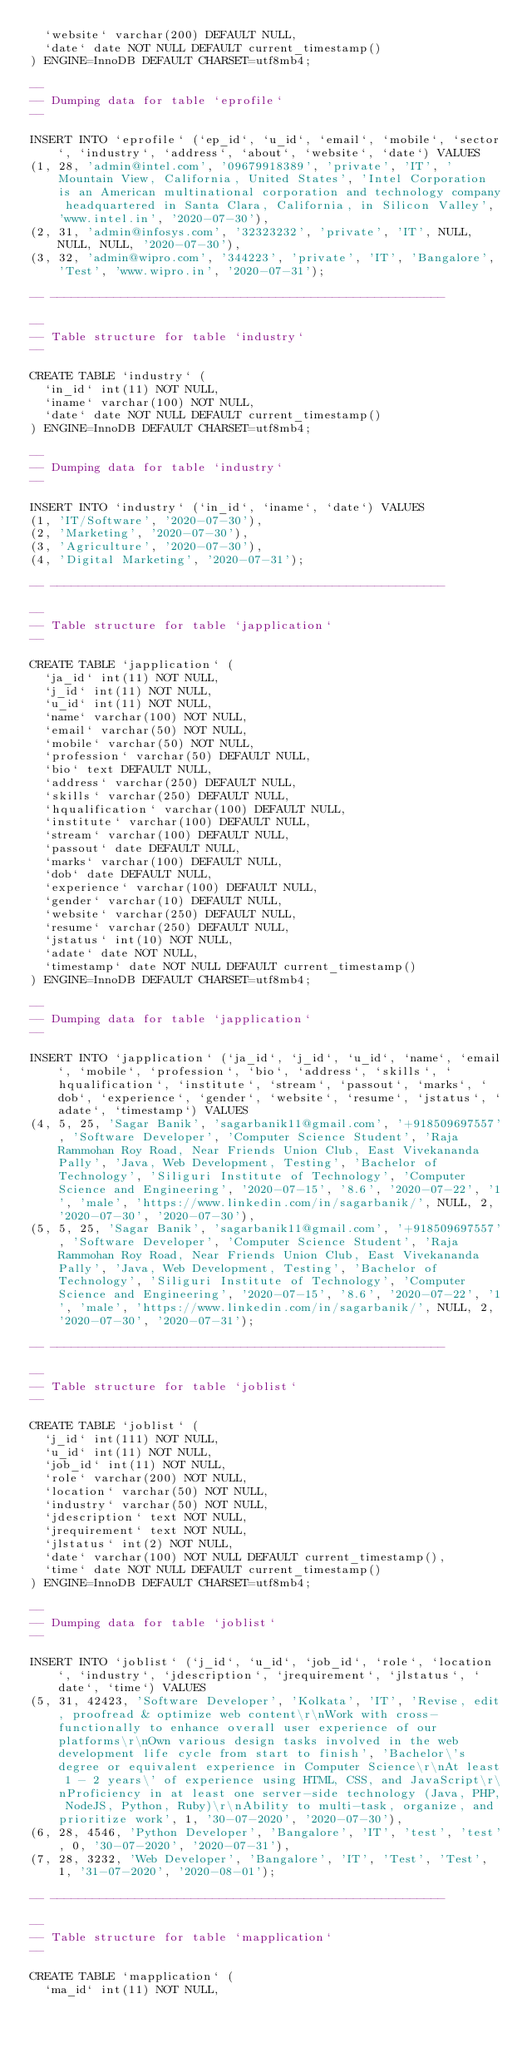Convert code to text. <code><loc_0><loc_0><loc_500><loc_500><_SQL_>  `website` varchar(200) DEFAULT NULL,
  `date` date NOT NULL DEFAULT current_timestamp()
) ENGINE=InnoDB DEFAULT CHARSET=utf8mb4;

--
-- Dumping data for table `eprofile`
--

INSERT INTO `eprofile` (`ep_id`, `u_id`, `email`, `mobile`, `sector`, `industry`, `address`, `about`, `website`, `date`) VALUES
(1, 28, 'admin@intel.com', '09679918389', 'private', 'IT', ' Mountain View, California, United States', 'Intel Corporation is an American multinational corporation and technology company headquartered in Santa Clara, California, in Silicon Valley', 'www.intel.in', '2020-07-30'),
(2, 31, 'admin@infosys.com', '32323232', 'private', 'IT', NULL, NULL, NULL, '2020-07-30'),
(3, 32, 'admin@wipro.com', '344223', 'private', 'IT', 'Bangalore', 'Test', 'www.wipro.in', '2020-07-31');

-- --------------------------------------------------------

--
-- Table structure for table `industry`
--

CREATE TABLE `industry` (
  `in_id` int(11) NOT NULL,
  `iname` varchar(100) NOT NULL,
  `date` date NOT NULL DEFAULT current_timestamp()
) ENGINE=InnoDB DEFAULT CHARSET=utf8mb4;

--
-- Dumping data for table `industry`
--

INSERT INTO `industry` (`in_id`, `iname`, `date`) VALUES
(1, 'IT/Software', '2020-07-30'),
(2, 'Marketing', '2020-07-30'),
(3, 'Agriculture', '2020-07-30'),
(4, 'Digital Marketing', '2020-07-31');

-- --------------------------------------------------------

--
-- Table structure for table `japplication`
--

CREATE TABLE `japplication` (
  `ja_id` int(11) NOT NULL,
  `j_id` int(11) NOT NULL,
  `u_id` int(11) NOT NULL,
  `name` varchar(100) NOT NULL,
  `email` varchar(50) NOT NULL,
  `mobile` varchar(50) NOT NULL,
  `profession` varchar(50) DEFAULT NULL,
  `bio` text DEFAULT NULL,
  `address` varchar(250) DEFAULT NULL,
  `skills` varchar(250) DEFAULT NULL,
  `hqualification` varchar(100) DEFAULT NULL,
  `institute` varchar(100) DEFAULT NULL,
  `stream` varchar(100) DEFAULT NULL,
  `passout` date DEFAULT NULL,
  `marks` varchar(100) DEFAULT NULL,
  `dob` date DEFAULT NULL,
  `experience` varchar(100) DEFAULT NULL,
  `gender` varchar(10) DEFAULT NULL,
  `website` varchar(250) DEFAULT NULL,
  `resume` varchar(250) DEFAULT NULL,
  `jstatus` int(10) NOT NULL,
  `adate` date NOT NULL,
  `timestamp` date NOT NULL DEFAULT current_timestamp()
) ENGINE=InnoDB DEFAULT CHARSET=utf8mb4;

--
-- Dumping data for table `japplication`
--

INSERT INTO `japplication` (`ja_id`, `j_id`, `u_id`, `name`, `email`, `mobile`, `profession`, `bio`, `address`, `skills`, `hqualification`, `institute`, `stream`, `passout`, `marks`, `dob`, `experience`, `gender`, `website`, `resume`, `jstatus`, `adate`, `timestamp`) VALUES
(4, 5, 25, 'Sagar Banik', 'sagarbanik11@gmail.com', '+918509697557', 'Software Developer', 'Computer Science Student', 'Raja Rammohan Roy Road, Near Friends Union Club, East Vivekananda Pally', 'Java, Web Development, Testing', 'Bachelor of Technology', 'Siliguri Institute of Technology', 'Computer Science and Engineering', '2020-07-15', '8.6', '2020-07-22', '1', 'male', 'https://www.linkedin.com/in/sagarbanik/', NULL, 2, '2020-07-30', '2020-07-30'),
(5, 5, 25, 'Sagar Banik', 'sagarbanik11@gmail.com', '+918509697557', 'Software Developer', 'Computer Science Student', 'Raja Rammohan Roy Road, Near Friends Union Club, East Vivekananda Pally', 'Java, Web Development, Testing', 'Bachelor of Technology', 'Siliguri Institute of Technology', 'Computer Science and Engineering', '2020-07-15', '8.6', '2020-07-22', '1', 'male', 'https://www.linkedin.com/in/sagarbanik/', NULL, 2, '2020-07-30', '2020-07-31');

-- --------------------------------------------------------

--
-- Table structure for table `joblist`
--

CREATE TABLE `joblist` (
  `j_id` int(111) NOT NULL,
  `u_id` int(11) NOT NULL,
  `job_id` int(11) NOT NULL,
  `role` varchar(200) NOT NULL,
  `location` varchar(50) NOT NULL,
  `industry` varchar(50) NOT NULL,
  `jdescription` text NOT NULL,
  `jrequirement` text NOT NULL,
  `jlstatus` int(2) NOT NULL,
  `date` varchar(100) NOT NULL DEFAULT current_timestamp(),
  `time` date NOT NULL DEFAULT current_timestamp()
) ENGINE=InnoDB DEFAULT CHARSET=utf8mb4;

--
-- Dumping data for table `joblist`
--

INSERT INTO `joblist` (`j_id`, `u_id`, `job_id`, `role`, `location`, `industry`, `jdescription`, `jrequirement`, `jlstatus`, `date`, `time`) VALUES
(5, 31, 42423, 'Software Developer', 'Kolkata', 'IT', 'Revise, edit, proofread & optimize web content\r\nWork with cross-functionally to enhance overall user experience of our platforms\r\nOwn various design tasks involved in the web development life cycle from start to finish', 'Bachelor\'s degree or equivalent experience in Computer Science\r\nAt least 1 - 2 years\' of experience using HTML, CSS, and JavaScript\r\nProficiency in at least one server-side technology (Java, PHP, NodeJS, Python, Ruby)\r\nAbility to multi-task, organize, and prioritize work', 1, '30-07-2020', '2020-07-30'),
(6, 28, 4546, 'Python Developer', 'Bangalore', 'IT', 'test', 'test', 0, '30-07-2020', '2020-07-31'),
(7, 28, 3232, 'Web Developer', 'Bangalore', 'IT', 'Test', 'Test', 1, '31-07-2020', '2020-08-01');

-- --------------------------------------------------------

--
-- Table structure for table `mapplication`
--

CREATE TABLE `mapplication` (
  `ma_id` int(11) NOT NULL,</code> 